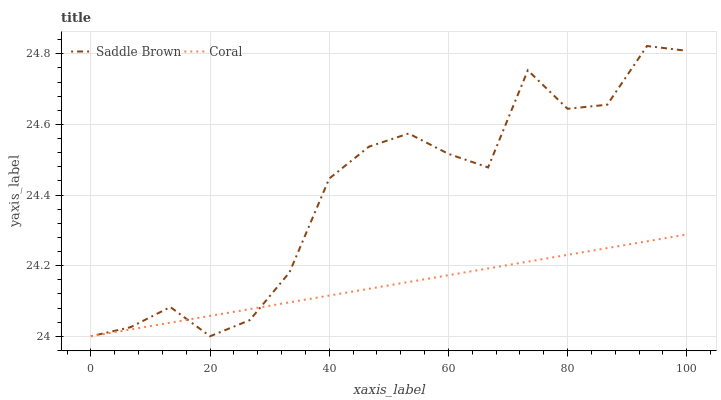Does Coral have the minimum area under the curve?
Answer yes or no. Yes. Does Saddle Brown have the maximum area under the curve?
Answer yes or no. Yes. Does Saddle Brown have the minimum area under the curve?
Answer yes or no. No. Is Coral the smoothest?
Answer yes or no. Yes. Is Saddle Brown the roughest?
Answer yes or no. Yes. Is Saddle Brown the smoothest?
Answer yes or no. No. Does Coral have the lowest value?
Answer yes or no. Yes. Does Saddle Brown have the highest value?
Answer yes or no. Yes. Does Saddle Brown intersect Coral?
Answer yes or no. Yes. Is Saddle Brown less than Coral?
Answer yes or no. No. Is Saddle Brown greater than Coral?
Answer yes or no. No. 